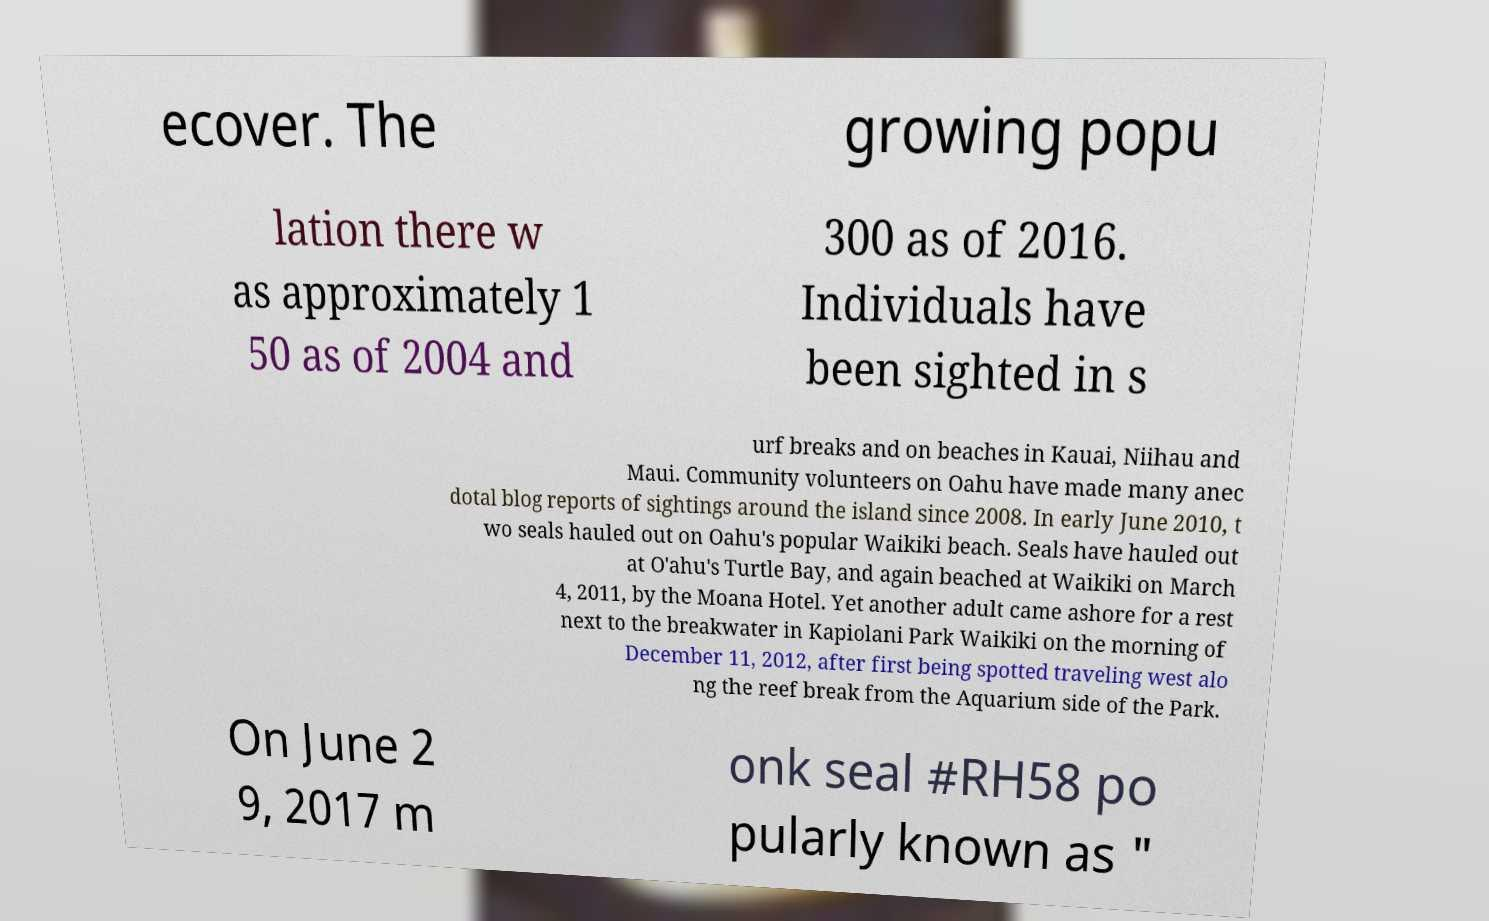Could you extract and type out the text from this image? ecover. The growing popu lation there w as approximately 1 50 as of 2004 and 300 as of 2016. Individuals have been sighted in s urf breaks and on beaches in Kauai, Niihau and Maui. Community volunteers on Oahu have made many anec dotal blog reports of sightings around the island since 2008. In early June 2010, t wo seals hauled out on Oahu's popular Waikiki beach. Seals have hauled out at O'ahu's Turtle Bay, and again beached at Waikiki on March 4, 2011, by the Moana Hotel. Yet another adult came ashore for a rest next to the breakwater in Kapiolani Park Waikiki on the morning of December 11, 2012, after first being spotted traveling west alo ng the reef break from the Aquarium side of the Park. On June 2 9, 2017 m onk seal #RH58 po pularly known as " 